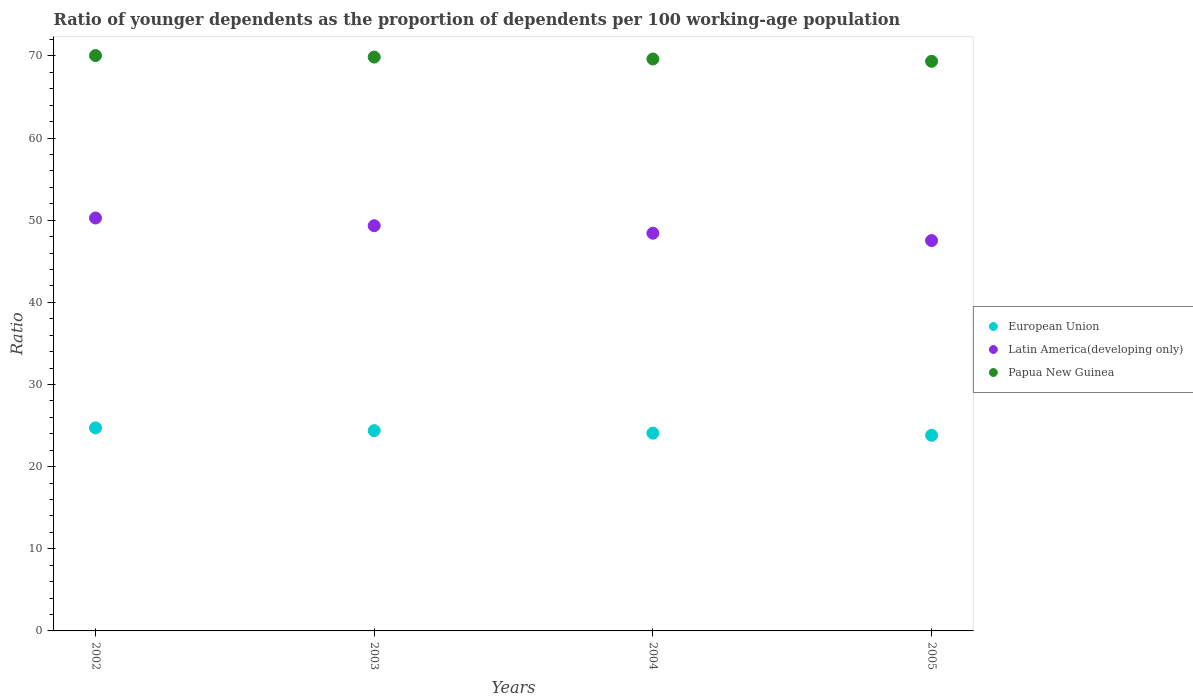What is the age dependency ratio(young) in Papua New Guinea in 2005?
Make the answer very short. 69.34. Across all years, what is the maximum age dependency ratio(young) in Papua New Guinea?
Give a very brief answer. 70.04. Across all years, what is the minimum age dependency ratio(young) in Latin America(developing only)?
Provide a short and direct response. 47.52. In which year was the age dependency ratio(young) in European Union maximum?
Ensure brevity in your answer.  2002. In which year was the age dependency ratio(young) in Papua New Guinea minimum?
Provide a short and direct response. 2005. What is the total age dependency ratio(young) in Papua New Guinea in the graph?
Give a very brief answer. 278.84. What is the difference between the age dependency ratio(young) in Latin America(developing only) in 2003 and that in 2004?
Your answer should be very brief. 0.92. What is the difference between the age dependency ratio(young) in Latin America(developing only) in 2004 and the age dependency ratio(young) in Papua New Guinea in 2003?
Offer a very short reply. -21.44. What is the average age dependency ratio(young) in Latin America(developing only) per year?
Make the answer very short. 48.88. In the year 2002, what is the difference between the age dependency ratio(young) in Latin America(developing only) and age dependency ratio(young) in Papua New Guinea?
Your answer should be compact. -19.77. In how many years, is the age dependency ratio(young) in Papua New Guinea greater than 36?
Offer a terse response. 4. What is the ratio of the age dependency ratio(young) in Latin America(developing only) in 2002 to that in 2003?
Your response must be concise. 1.02. Is the difference between the age dependency ratio(young) in Latin America(developing only) in 2004 and 2005 greater than the difference between the age dependency ratio(young) in Papua New Guinea in 2004 and 2005?
Your answer should be compact. Yes. What is the difference between the highest and the second highest age dependency ratio(young) in Papua New Guinea?
Provide a succinct answer. 0.19. What is the difference between the highest and the lowest age dependency ratio(young) in Papua New Guinea?
Offer a very short reply. 0.7. In how many years, is the age dependency ratio(young) in Papua New Guinea greater than the average age dependency ratio(young) in Papua New Guinea taken over all years?
Give a very brief answer. 2. Is the sum of the age dependency ratio(young) in Latin America(developing only) in 2004 and 2005 greater than the maximum age dependency ratio(young) in European Union across all years?
Your answer should be compact. Yes. Is it the case that in every year, the sum of the age dependency ratio(young) in Latin America(developing only) and age dependency ratio(young) in Papua New Guinea  is greater than the age dependency ratio(young) in European Union?
Provide a short and direct response. Yes. Does the age dependency ratio(young) in Papua New Guinea monotonically increase over the years?
Keep it short and to the point. No. Is the age dependency ratio(young) in European Union strictly greater than the age dependency ratio(young) in Latin America(developing only) over the years?
Give a very brief answer. No. How many dotlines are there?
Offer a very short reply. 3. How many years are there in the graph?
Ensure brevity in your answer.  4. Does the graph contain any zero values?
Your answer should be very brief. No. Does the graph contain grids?
Your answer should be compact. No. How many legend labels are there?
Make the answer very short. 3. What is the title of the graph?
Make the answer very short. Ratio of younger dependents as the proportion of dependents per 100 working-age population. What is the label or title of the X-axis?
Ensure brevity in your answer.  Years. What is the label or title of the Y-axis?
Provide a short and direct response. Ratio. What is the Ratio of European Union in 2002?
Your answer should be compact. 24.71. What is the Ratio of Latin America(developing only) in 2002?
Offer a terse response. 50.26. What is the Ratio in Papua New Guinea in 2002?
Your response must be concise. 70.04. What is the Ratio in European Union in 2003?
Offer a terse response. 24.38. What is the Ratio of Latin America(developing only) in 2003?
Make the answer very short. 49.33. What is the Ratio in Papua New Guinea in 2003?
Give a very brief answer. 69.85. What is the Ratio in European Union in 2004?
Your answer should be very brief. 24.08. What is the Ratio of Latin America(developing only) in 2004?
Make the answer very short. 48.41. What is the Ratio of Papua New Guinea in 2004?
Your answer should be compact. 69.62. What is the Ratio of European Union in 2005?
Your answer should be very brief. 23.81. What is the Ratio of Latin America(developing only) in 2005?
Give a very brief answer. 47.52. What is the Ratio of Papua New Guinea in 2005?
Provide a succinct answer. 69.34. Across all years, what is the maximum Ratio of European Union?
Ensure brevity in your answer.  24.71. Across all years, what is the maximum Ratio of Latin America(developing only)?
Provide a succinct answer. 50.26. Across all years, what is the maximum Ratio of Papua New Guinea?
Your answer should be very brief. 70.04. Across all years, what is the minimum Ratio of European Union?
Give a very brief answer. 23.81. Across all years, what is the minimum Ratio of Latin America(developing only)?
Offer a terse response. 47.52. Across all years, what is the minimum Ratio in Papua New Guinea?
Make the answer very short. 69.34. What is the total Ratio in European Union in the graph?
Keep it short and to the point. 96.99. What is the total Ratio in Latin America(developing only) in the graph?
Provide a succinct answer. 195.51. What is the total Ratio in Papua New Guinea in the graph?
Provide a succinct answer. 278.84. What is the difference between the Ratio in European Union in 2002 and that in 2003?
Provide a succinct answer. 0.33. What is the difference between the Ratio of Latin America(developing only) in 2002 and that in 2003?
Your answer should be very brief. 0.94. What is the difference between the Ratio in Papua New Guinea in 2002 and that in 2003?
Your answer should be compact. 0.19. What is the difference between the Ratio of European Union in 2002 and that in 2004?
Ensure brevity in your answer.  0.64. What is the difference between the Ratio of Latin America(developing only) in 2002 and that in 2004?
Provide a succinct answer. 1.85. What is the difference between the Ratio of Papua New Guinea in 2002 and that in 2004?
Your answer should be very brief. 0.42. What is the difference between the Ratio in European Union in 2002 and that in 2005?
Offer a terse response. 0.9. What is the difference between the Ratio in Latin America(developing only) in 2002 and that in 2005?
Offer a terse response. 2.75. What is the difference between the Ratio of Papua New Guinea in 2002 and that in 2005?
Make the answer very short. 0.7. What is the difference between the Ratio in European Union in 2003 and that in 2004?
Give a very brief answer. 0.3. What is the difference between the Ratio in Latin America(developing only) in 2003 and that in 2004?
Keep it short and to the point. 0.92. What is the difference between the Ratio in Papua New Guinea in 2003 and that in 2004?
Offer a terse response. 0.23. What is the difference between the Ratio of European Union in 2003 and that in 2005?
Make the answer very short. 0.57. What is the difference between the Ratio of Latin America(developing only) in 2003 and that in 2005?
Ensure brevity in your answer.  1.81. What is the difference between the Ratio of Papua New Guinea in 2003 and that in 2005?
Give a very brief answer. 0.51. What is the difference between the Ratio of European Union in 2004 and that in 2005?
Provide a succinct answer. 0.26. What is the difference between the Ratio of Latin America(developing only) in 2004 and that in 2005?
Ensure brevity in your answer.  0.89. What is the difference between the Ratio in Papua New Guinea in 2004 and that in 2005?
Offer a very short reply. 0.28. What is the difference between the Ratio of European Union in 2002 and the Ratio of Latin America(developing only) in 2003?
Provide a short and direct response. -24.61. What is the difference between the Ratio in European Union in 2002 and the Ratio in Papua New Guinea in 2003?
Your answer should be very brief. -45.14. What is the difference between the Ratio of Latin America(developing only) in 2002 and the Ratio of Papua New Guinea in 2003?
Make the answer very short. -19.59. What is the difference between the Ratio in European Union in 2002 and the Ratio in Latin America(developing only) in 2004?
Keep it short and to the point. -23.7. What is the difference between the Ratio in European Union in 2002 and the Ratio in Papua New Guinea in 2004?
Ensure brevity in your answer.  -44.9. What is the difference between the Ratio of Latin America(developing only) in 2002 and the Ratio of Papua New Guinea in 2004?
Provide a succinct answer. -19.35. What is the difference between the Ratio in European Union in 2002 and the Ratio in Latin America(developing only) in 2005?
Ensure brevity in your answer.  -22.8. What is the difference between the Ratio of European Union in 2002 and the Ratio of Papua New Guinea in 2005?
Offer a terse response. -44.62. What is the difference between the Ratio of Latin America(developing only) in 2002 and the Ratio of Papua New Guinea in 2005?
Your answer should be very brief. -19.07. What is the difference between the Ratio of European Union in 2003 and the Ratio of Latin America(developing only) in 2004?
Your answer should be compact. -24.03. What is the difference between the Ratio in European Union in 2003 and the Ratio in Papua New Guinea in 2004?
Your response must be concise. -45.24. What is the difference between the Ratio of Latin America(developing only) in 2003 and the Ratio of Papua New Guinea in 2004?
Provide a succinct answer. -20.29. What is the difference between the Ratio in European Union in 2003 and the Ratio in Latin America(developing only) in 2005?
Provide a short and direct response. -23.13. What is the difference between the Ratio of European Union in 2003 and the Ratio of Papua New Guinea in 2005?
Ensure brevity in your answer.  -44.96. What is the difference between the Ratio in Latin America(developing only) in 2003 and the Ratio in Papua New Guinea in 2005?
Give a very brief answer. -20.01. What is the difference between the Ratio in European Union in 2004 and the Ratio in Latin America(developing only) in 2005?
Make the answer very short. -23.44. What is the difference between the Ratio in European Union in 2004 and the Ratio in Papua New Guinea in 2005?
Keep it short and to the point. -45.26. What is the difference between the Ratio in Latin America(developing only) in 2004 and the Ratio in Papua New Guinea in 2005?
Offer a terse response. -20.93. What is the average Ratio in European Union per year?
Provide a succinct answer. 24.25. What is the average Ratio in Latin America(developing only) per year?
Offer a terse response. 48.88. What is the average Ratio in Papua New Guinea per year?
Keep it short and to the point. 69.71. In the year 2002, what is the difference between the Ratio in European Union and Ratio in Latin America(developing only)?
Offer a very short reply. -25.55. In the year 2002, what is the difference between the Ratio in European Union and Ratio in Papua New Guinea?
Make the answer very short. -45.32. In the year 2002, what is the difference between the Ratio of Latin America(developing only) and Ratio of Papua New Guinea?
Your answer should be compact. -19.77. In the year 2003, what is the difference between the Ratio in European Union and Ratio in Latin America(developing only)?
Your response must be concise. -24.94. In the year 2003, what is the difference between the Ratio of European Union and Ratio of Papua New Guinea?
Make the answer very short. -45.47. In the year 2003, what is the difference between the Ratio in Latin America(developing only) and Ratio in Papua New Guinea?
Your answer should be compact. -20.53. In the year 2004, what is the difference between the Ratio in European Union and Ratio in Latin America(developing only)?
Offer a very short reply. -24.33. In the year 2004, what is the difference between the Ratio of European Union and Ratio of Papua New Guinea?
Your answer should be compact. -45.54. In the year 2004, what is the difference between the Ratio of Latin America(developing only) and Ratio of Papua New Guinea?
Give a very brief answer. -21.21. In the year 2005, what is the difference between the Ratio in European Union and Ratio in Latin America(developing only)?
Make the answer very short. -23.7. In the year 2005, what is the difference between the Ratio in European Union and Ratio in Papua New Guinea?
Your response must be concise. -45.52. In the year 2005, what is the difference between the Ratio of Latin America(developing only) and Ratio of Papua New Guinea?
Offer a very short reply. -21.82. What is the ratio of the Ratio of European Union in 2002 to that in 2003?
Your answer should be very brief. 1.01. What is the ratio of the Ratio of European Union in 2002 to that in 2004?
Provide a short and direct response. 1.03. What is the ratio of the Ratio of Latin America(developing only) in 2002 to that in 2004?
Your response must be concise. 1.04. What is the ratio of the Ratio of European Union in 2002 to that in 2005?
Provide a succinct answer. 1.04. What is the ratio of the Ratio of Latin America(developing only) in 2002 to that in 2005?
Ensure brevity in your answer.  1.06. What is the ratio of the Ratio of European Union in 2003 to that in 2004?
Provide a short and direct response. 1.01. What is the ratio of the Ratio in Latin America(developing only) in 2003 to that in 2004?
Your answer should be compact. 1.02. What is the ratio of the Ratio in European Union in 2003 to that in 2005?
Make the answer very short. 1.02. What is the ratio of the Ratio in Latin America(developing only) in 2003 to that in 2005?
Provide a short and direct response. 1.04. What is the ratio of the Ratio in Papua New Guinea in 2003 to that in 2005?
Offer a very short reply. 1.01. What is the ratio of the Ratio of Latin America(developing only) in 2004 to that in 2005?
Keep it short and to the point. 1.02. What is the difference between the highest and the second highest Ratio in Latin America(developing only)?
Provide a short and direct response. 0.94. What is the difference between the highest and the second highest Ratio in Papua New Guinea?
Offer a terse response. 0.19. What is the difference between the highest and the lowest Ratio in European Union?
Your answer should be compact. 0.9. What is the difference between the highest and the lowest Ratio in Latin America(developing only)?
Offer a very short reply. 2.75. What is the difference between the highest and the lowest Ratio of Papua New Guinea?
Give a very brief answer. 0.7. 